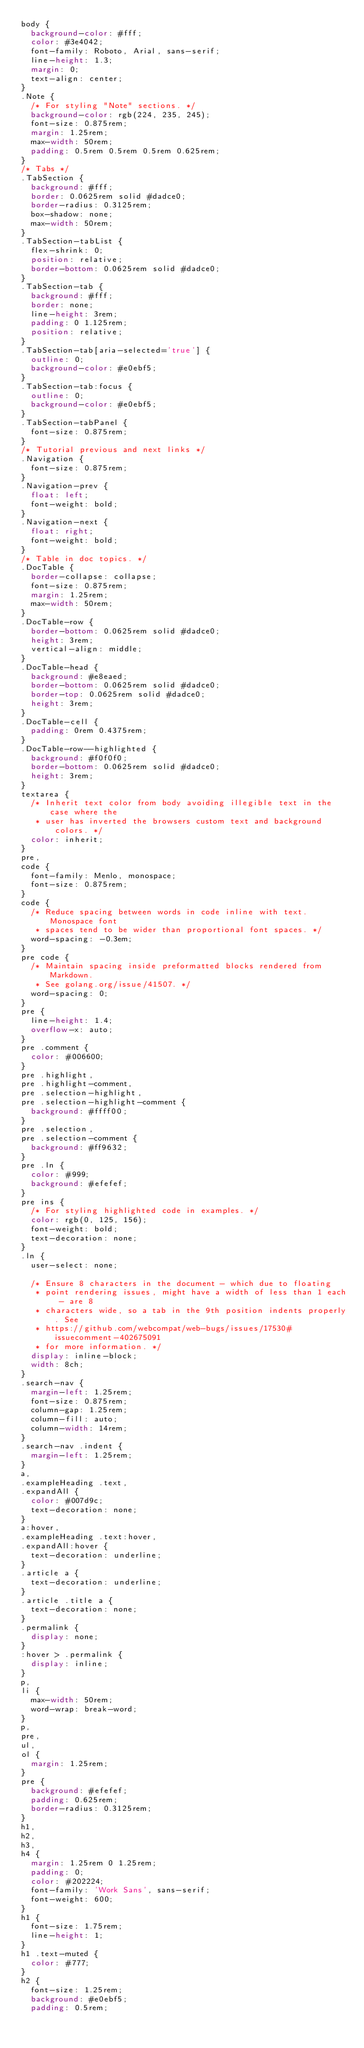Convert code to text. <code><loc_0><loc_0><loc_500><loc_500><_CSS_>body {
  background-color: #fff;
  color: #3e4042;
  font-family: Roboto, Arial, sans-serif;
  line-height: 1.3;
  margin: 0;
  text-align: center;
}
.Note {
  /* For styling "Note" sections. */
  background-color: rgb(224, 235, 245);
  font-size: 0.875rem;
  margin: 1.25rem;
  max-width: 50rem;
  padding: 0.5rem 0.5rem 0.5rem 0.625rem;
}
/* Tabs */
.TabSection {
  background: #fff;
  border: 0.0625rem solid #dadce0;
  border-radius: 0.3125rem;
  box-shadow: none;
  max-width: 50rem;
}
.TabSection-tabList {
  flex-shrink: 0;
  position: relative;
  border-bottom: 0.0625rem solid #dadce0;
}
.TabSection-tab {
  background: #fff;
  border: none;
  line-height: 3rem;
  padding: 0 1.125rem;
  position: relative;
}
.TabSection-tab[aria-selected='true'] {
  outline: 0;
  background-color: #e0ebf5;
}
.TabSection-tab:focus {
  outline: 0;
  background-color: #e0ebf5;
}
.TabSection-tabPanel {
  font-size: 0.875rem;
}
/* Tutorial previous and next links */
.Navigation {
  font-size: 0.875rem;
}
.Navigation-prev {
  float: left;
  font-weight: bold;
}
.Navigation-next {
  float: right;
  font-weight: bold;
}
/* Table in doc topics. */
.DocTable {
  border-collapse: collapse;
  font-size: 0.875rem;
  margin: 1.25rem;
  max-width: 50rem;
}
.DocTable-row {
  border-bottom: 0.0625rem solid #dadce0;
  height: 3rem;
  vertical-align: middle;
}
.DocTable-head {
  background: #e8eaed;
  border-bottom: 0.0625rem solid #dadce0;
  border-top: 0.0625rem solid #dadce0;
  height: 3rem;
}
.DocTable-cell {
  padding: 0rem 0.4375rem;
}
.DocTable-row--highlighted {
  background: #f0f0f0;
  border-bottom: 0.0625rem solid #dadce0;
  height: 3rem;
}
textarea {
  /* Inherit text color from body avoiding illegible text in the case where the
   * user has inverted the browsers custom text and background colors. */
  color: inherit;
}
pre,
code {
  font-family: Menlo, monospace;
  font-size: 0.875rem;
}
code {
  /* Reduce spacing between words in code inline with text. Monospace font
   * spaces tend to be wider than proportional font spaces. */
  word-spacing: -0.3em;
}
pre code {
  /* Maintain spacing inside preformatted blocks rendered from Markdown.
   * See golang.org/issue/41507. */
  word-spacing: 0;
}
pre {
  line-height: 1.4;
  overflow-x: auto;
}
pre .comment {
  color: #006600;
}
pre .highlight,
pre .highlight-comment,
pre .selection-highlight,
pre .selection-highlight-comment {
  background: #ffff00;
}
pre .selection,
pre .selection-comment {
  background: #ff9632;
}
pre .ln {
  color: #999;
  background: #efefef;
}
pre ins {
  /* For styling highlighted code in examples. */
  color: rgb(0, 125, 156);
  font-weight: bold;
  text-decoration: none;
}
.ln {
  user-select: none;

  /* Ensure 8 characters in the document - which due to floating
   * point rendering issues, might have a width of less than 1 each - are 8
   * characters wide, so a tab in the 9th position indents properly. See
   * https://github.com/webcompat/web-bugs/issues/17530#issuecomment-402675091
   * for more information. */
  display: inline-block;
  width: 8ch;
}
.search-nav {
  margin-left: 1.25rem;
  font-size: 0.875rem;
  column-gap: 1.25rem;
  column-fill: auto;
  column-width: 14rem;
}
.search-nav .indent {
  margin-left: 1.25rem;
}
a,
.exampleHeading .text,
.expandAll {
  color: #007d9c;
  text-decoration: none;
}
a:hover,
.exampleHeading .text:hover,
.expandAll:hover {
  text-decoration: underline;
}
.article a {
  text-decoration: underline;
}
.article .title a {
  text-decoration: none;
}
.permalink {
  display: none;
}
:hover > .permalink {
  display: inline;
}
p,
li {
  max-width: 50rem;
  word-wrap: break-word;
}
p,
pre,
ul,
ol {
  margin: 1.25rem;
}
pre {
  background: #efefef;
  padding: 0.625rem;
  border-radius: 0.3125rem;
}
h1,
h2,
h3,
h4 {
  margin: 1.25rem 0 1.25rem;
  padding: 0;
  color: #202224;
  font-family: 'Work Sans', sans-serif;
  font-weight: 600;
}
h1 {
  font-size: 1.75rem;
  line-height: 1;
}
h1 .text-muted {
  color: #777;
}
h2 {
  font-size: 1.25rem;
  background: #e0ebf5;
  padding: 0.5rem;</code> 